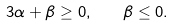<formula> <loc_0><loc_0><loc_500><loc_500>3 \alpha + \beta \geq 0 , \quad \beta \leq 0 .</formula> 